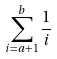<formula> <loc_0><loc_0><loc_500><loc_500>\sum _ { i = a + 1 } ^ { b } \frac { 1 } { i }</formula> 